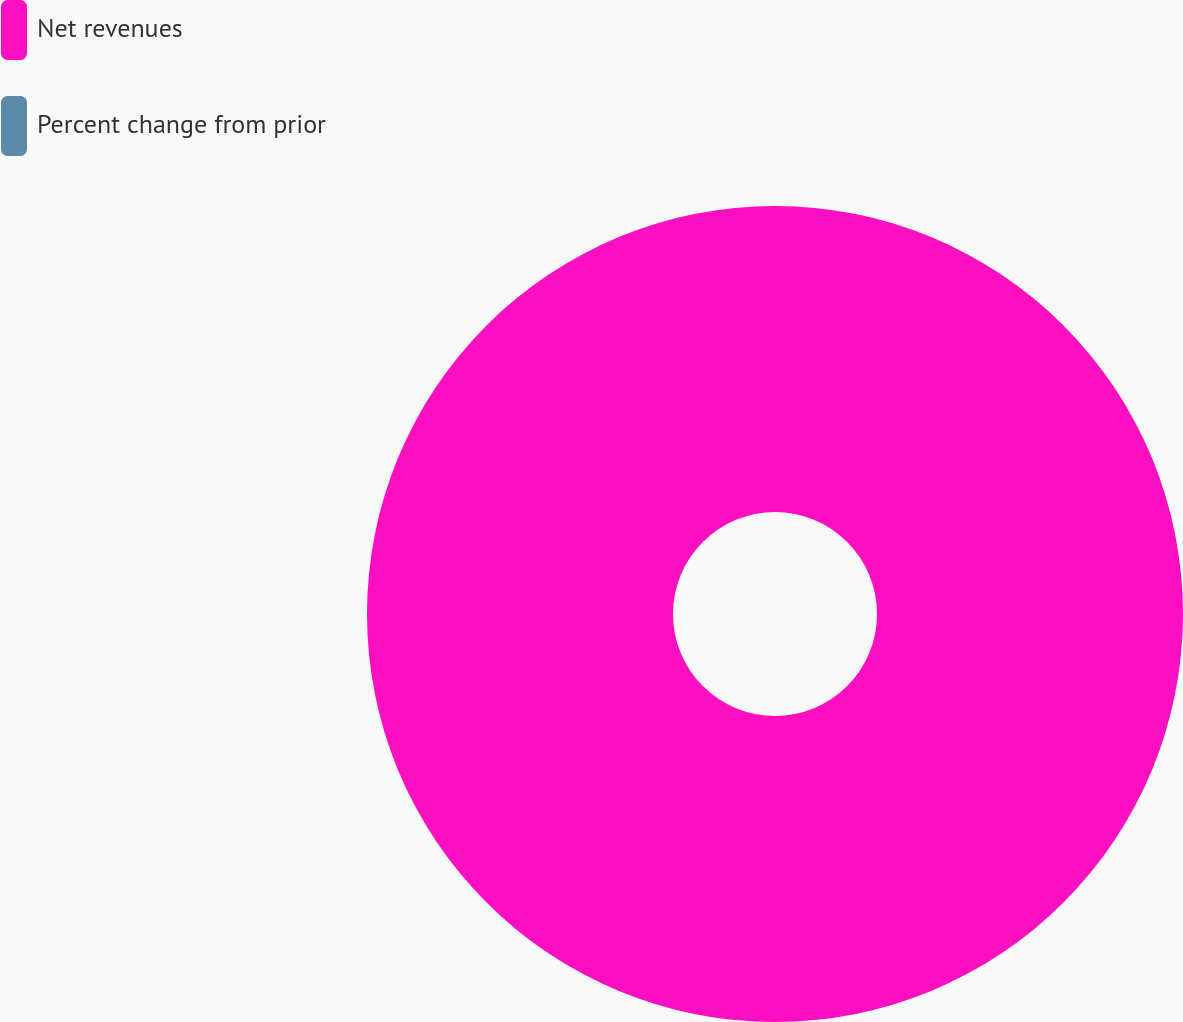Convert chart to OTSL. <chart><loc_0><loc_0><loc_500><loc_500><pie_chart><fcel>Net revenues<fcel>Percent change from prior<nl><fcel>100.0%<fcel>0.0%<nl></chart> 